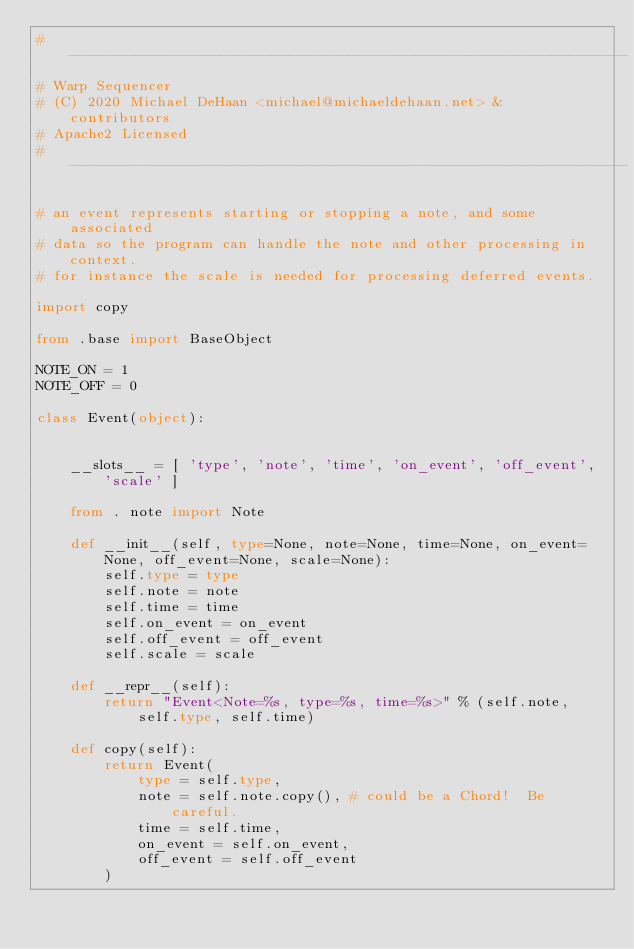Convert code to text. <code><loc_0><loc_0><loc_500><loc_500><_Python_># ------------------------------------------------------------------
# Warp Sequencer
# (C) 2020 Michael DeHaan <michael@michaeldehaan.net> & contributors
# Apache2 Licensed
# ------------------------------------------------------------------

# an event represents starting or stopping a note, and some associated
# data so the program can handle the note and other processing in context.
# for instance the scale is needed for processing deferred events.

import copy

from .base import BaseObject

NOTE_ON = 1
NOTE_OFF = 0

class Event(object):


    __slots__ = [ 'type', 'note', 'time', 'on_event', 'off_event', 'scale' ]

    from . note import Note

    def __init__(self, type=None, note=None, time=None, on_event=None, off_event=None, scale=None):
        self.type = type
        self.note = note
        self.time = time
        self.on_event = on_event
        self.off_event = off_event
        self.scale = scale

    def __repr__(self):
        return "Event<Note=%s, type=%s, time=%s>" % (self.note, self.type, self.time)

    def copy(self):
        return Event(
            type = self.type,
            note = self.note.copy(), # could be a Chord!  Be careful.
            time = self.time,
            on_event = self.on_event,
            off_event = self.off_event
        )
</code> 